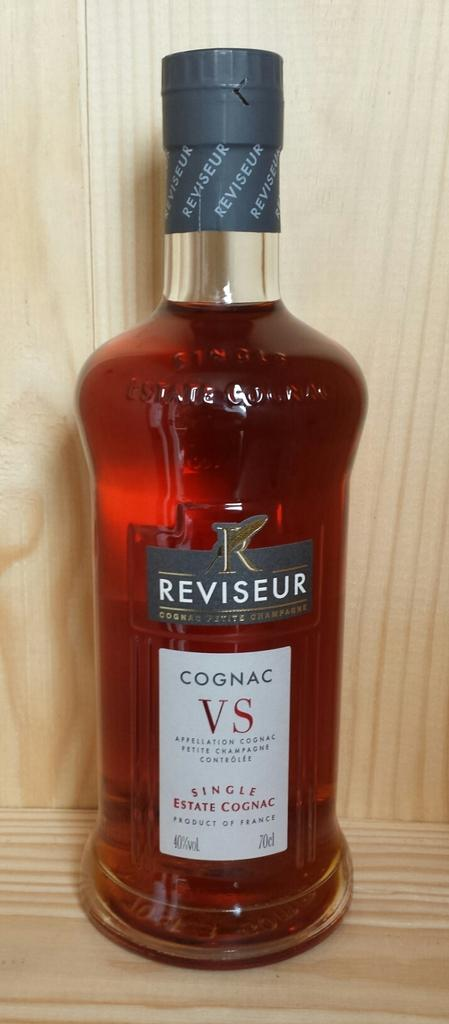<image>
Describe the image concisely. A bottle of Cognac doesn't appear to have been opened yet. 